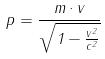Convert formula to latex. <formula><loc_0><loc_0><loc_500><loc_500>p = \frac { m \cdot v } { \sqrt { 1 - \frac { v ^ { 2 } } { c ^ { 2 } } } }</formula> 